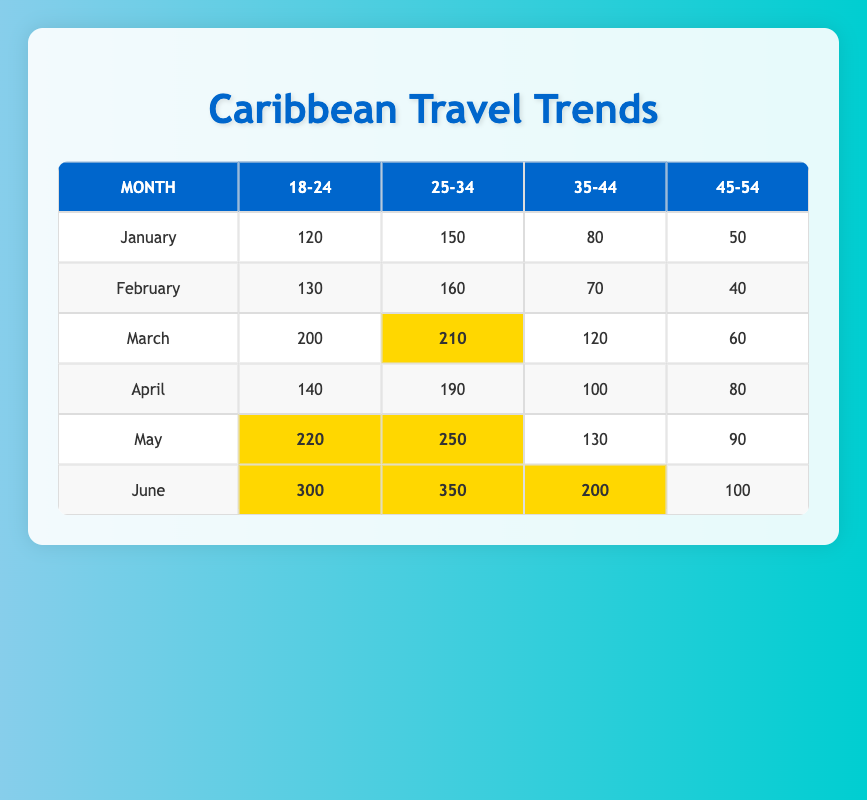What month had the highest number of travel packages sold for the age group 18-24? Looking at the 18-24 age group column, the highest number sold occurs in June with 300 packages.
Answer: June What is the total number of travel packages sold in February? Summing the values in February: 130 (18-24) + 160 (25-34) + 70 (35-44) + 40 (45-54) = 400.
Answer: 400 Which customer age group sold the least number of travel packages in April? In April, the numbers for each age group are 140 (18-24), 190 (25-34), 100 (35-44), and 80 (45-54). The least is 80 for the 45-54 age group.
Answer: 45-54 Is it true that March had more travel packages sold by the age group 35-44 than January? In March, 120 packages were sold in the 35-44 age group, while in January, only 80 were sold. Therefore, it is true.
Answer: Yes What is the average number of travel packages sold for the age group 25-34 over the six months? To calculate the average, sum the values for 25-34: 150 (Jan) + 160 (Feb) + 210 (Mar) + 190 (Apr) + 250 (May) + 350 (Jun) = 1310. Dividing by 6 gives 1310/6 = 218.33.
Answer: 218.33 What was the difference in travel packages sold between the age groups 18-24 and 35-44 for the month of May? In May, 220 packages were sold for 18-24 and 130 for 35-44, so the difference is 220 - 130 = 90.
Answer: 90 Which age group had higher sales in June, 25-34 or 35-44? In June, the sales were 350 for 25-34 and 200 for 35-44. Since 350 is greater than 200, 25-34 had higher sales.
Answer: 25-34 What is the total number of travel packages sold across all age groups in June? Adding together the packages sold in June gives: 300 (18-24) + 350 (25-34) + 200 (35-44) + 100 (45-54) = 950.
Answer: 950 